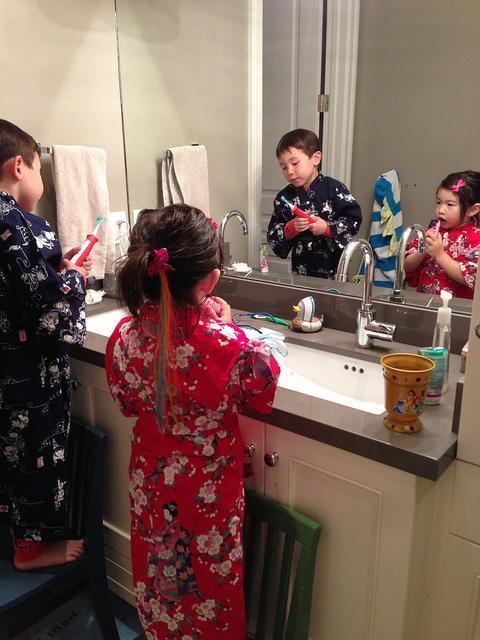How many chairs are there?
Give a very brief answer. 2. How many people are visible?
Give a very brief answer. 3. How many buses are parked?
Give a very brief answer. 0. 